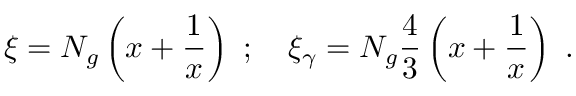<formula> <loc_0><loc_0><loc_500><loc_500>\xi = N _ { g } \left ( x + \frac { 1 } { x } \right ) ; \xi _ { \gamma } = N _ { g } \frac { 4 } { 3 } \left ( x + \frac { 1 } { x } \right ) .</formula> 